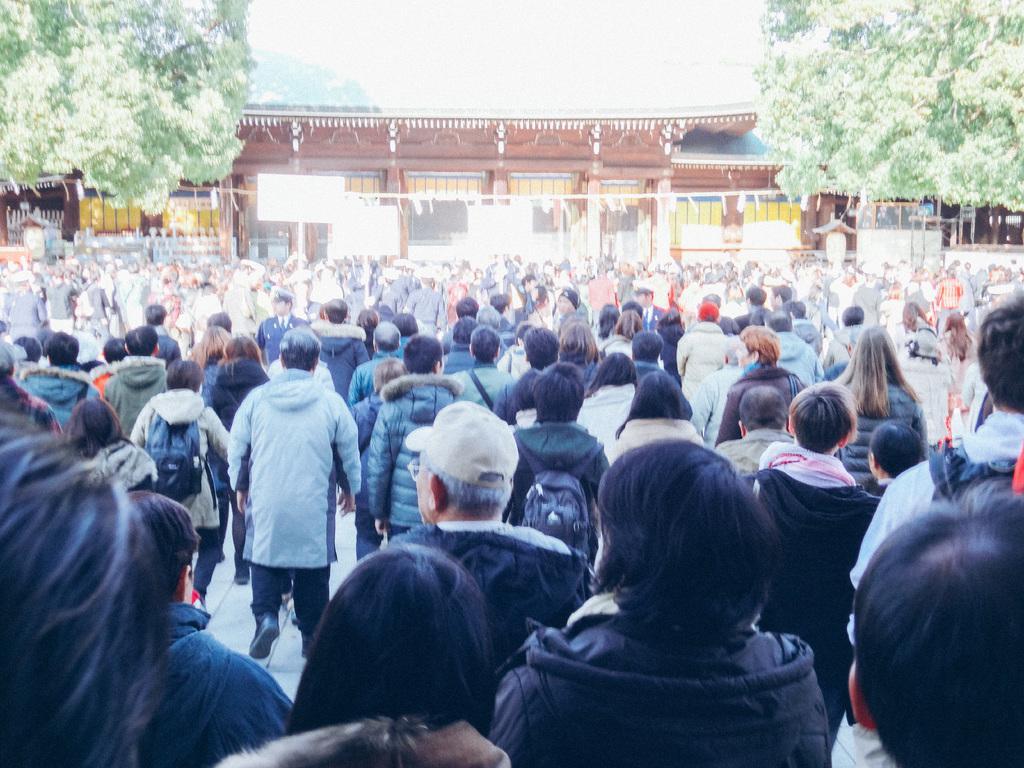Describe this image in one or two sentences. In the image there are many people standing. In the background there is a building. And also there are trees. 